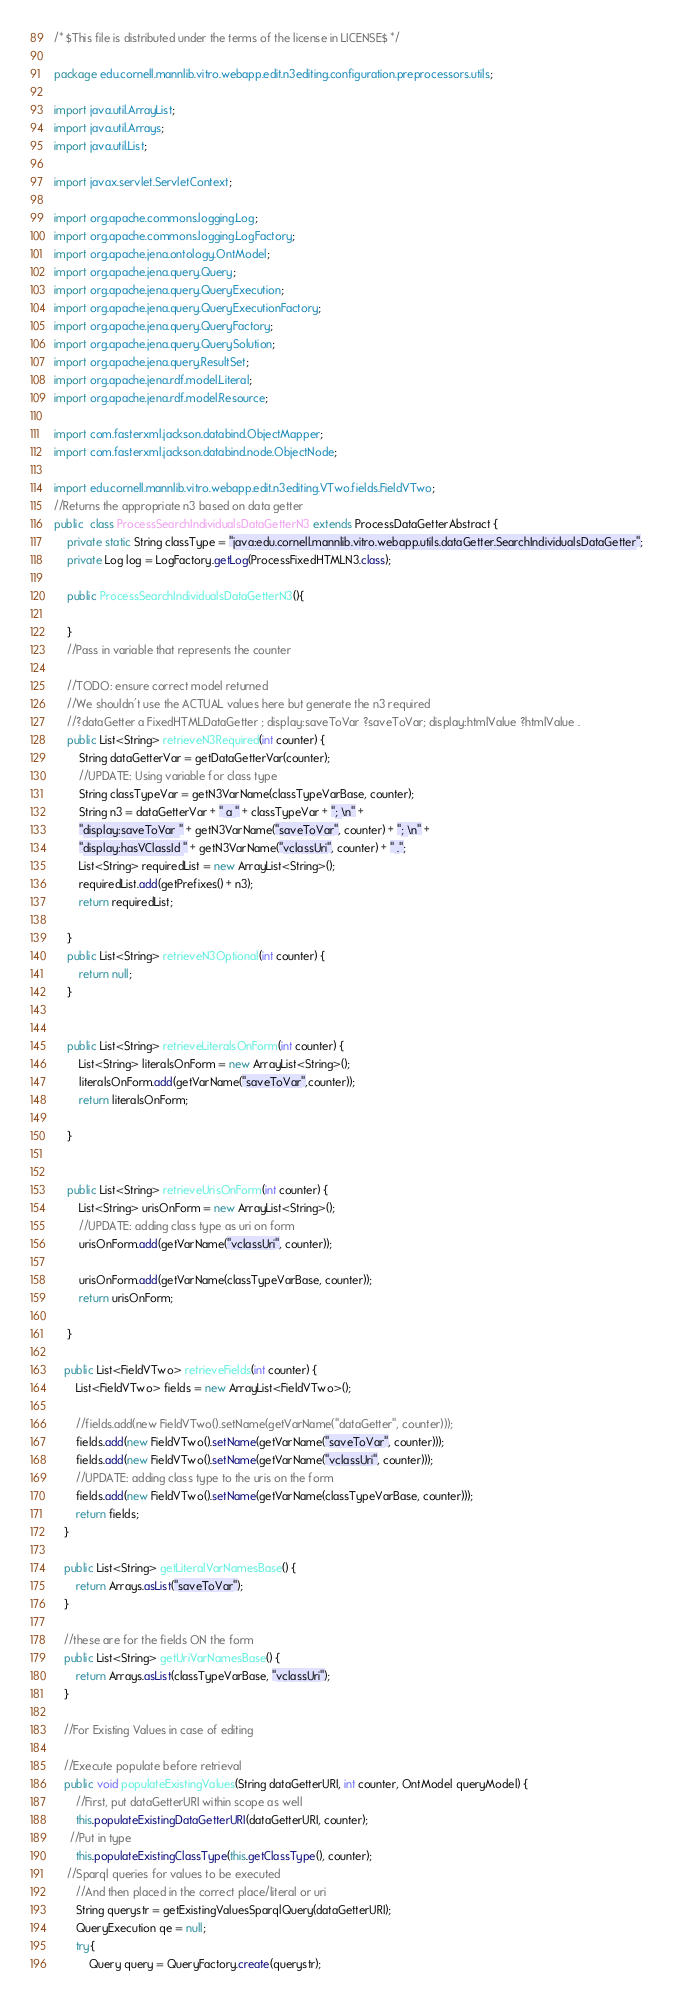Convert code to text. <code><loc_0><loc_0><loc_500><loc_500><_Java_>/* $This file is distributed under the terms of the license in LICENSE$ */

package edu.cornell.mannlib.vitro.webapp.edit.n3editing.configuration.preprocessors.utils;

import java.util.ArrayList;
import java.util.Arrays;
import java.util.List;

import javax.servlet.ServletContext;

import org.apache.commons.logging.Log;
import org.apache.commons.logging.LogFactory;
import org.apache.jena.ontology.OntModel;
import org.apache.jena.query.Query;
import org.apache.jena.query.QueryExecution;
import org.apache.jena.query.QueryExecutionFactory;
import org.apache.jena.query.QueryFactory;
import org.apache.jena.query.QuerySolution;
import org.apache.jena.query.ResultSet;
import org.apache.jena.rdf.model.Literal;
import org.apache.jena.rdf.model.Resource;

import com.fasterxml.jackson.databind.ObjectMapper;
import com.fasterxml.jackson.databind.node.ObjectNode;

import edu.cornell.mannlib.vitro.webapp.edit.n3editing.VTwo.fields.FieldVTwo;
//Returns the appropriate n3 based on data getter
public  class ProcessSearchIndividualsDataGetterN3 extends ProcessDataGetterAbstract {
	private static String classType = "java:edu.cornell.mannlib.vitro.webapp.utils.dataGetter.SearchIndividualsDataGetter";
	private Log log = LogFactory.getLog(ProcessFixedHTMLN3.class);

	public ProcessSearchIndividualsDataGetterN3(){
		
	}
	//Pass in variable that represents the counter 

	//TODO: ensure correct model returned
	//We shouldn't use the ACTUAL values here but generate the n3 required
	//?dataGetter a FixedHTMLDataGetter ; display:saveToVar ?saveToVar; display:htmlValue ?htmlValue .
    public List<String> retrieveN3Required(int counter) {
    	String dataGetterVar = getDataGetterVar(counter);
    	//UPDATE: Using variable for class type
    	String classTypeVar = getN3VarName(classTypeVarBase, counter);
    	String n3 = dataGetterVar + " a " + classTypeVar + "; \n" + 
    	"display:saveToVar " + getN3VarName("saveToVar", counter) + "; \n" + 
    	"display:hasVClassId " + getN3VarName("vclassUri", counter) + " .";
    	List<String> requiredList = new ArrayList<String>();
    	requiredList.add(getPrefixes() + n3);
    	return requiredList;
    	
    }
    public List<String> retrieveN3Optional(int counter) {
    	return null;
    }
  
    
    public List<String> retrieveLiteralsOnForm(int counter) {
    	List<String> literalsOnForm = new ArrayList<String>();
    	literalsOnForm.add(getVarName("saveToVar",counter));
    	return literalsOnForm;
    	
    }
    
     
    public List<String> retrieveUrisOnForm(int counter) {
    	List<String> urisOnForm = new ArrayList<String>();
    	//UPDATE: adding class type as uri on form
    	urisOnForm.add(getVarName("vclassUri", counter));

    	urisOnForm.add(getVarName(classTypeVarBase, counter));
    	return urisOnForm;
    	
    }
    
   public List<FieldVTwo> retrieveFields(int counter) {
	   List<FieldVTwo> fields = new ArrayList<FieldVTwo>();
	  
	   //fields.add(new FieldVTwo().setName(getVarName("dataGetter", counter)));
	   fields.add(new FieldVTwo().setName(getVarName("saveToVar", counter)));
	   fields.add(new FieldVTwo().setName(getVarName("vclassUri", counter)));
	   //UPDATE: adding class type to the uris on the form
	   fields.add(new FieldVTwo().setName(getVarName(classTypeVarBase, counter)));
	   return fields;
   }
   
   public List<String> getLiteralVarNamesBase() {
	   return Arrays.asList("saveToVar");   
   }

   //these are for the fields ON the form
   public List<String> getUriVarNamesBase() {
	   return Arrays.asList(classTypeVarBase, "vclassUri");   
   }

   //For Existing Values in case of editing
  
   //Execute populate before retrieval
   public void populateExistingValues(String dataGetterURI, int counter, OntModel queryModel) {
	   //First, put dataGetterURI within scope as well
	   this.populateExistingDataGetterURI(dataGetterURI, counter);
	 //Put in type
	   this.populateExistingClassType(this.getClassType(), counter);
	//Sparql queries for values to be executed
	   //And then placed in the correct place/literal or uri
	   String querystr = getExistingValuesSparqlQuery(dataGetterURI);
	   QueryExecution qe = null;
       try{
           Query query = QueryFactory.create(querystr);</code> 